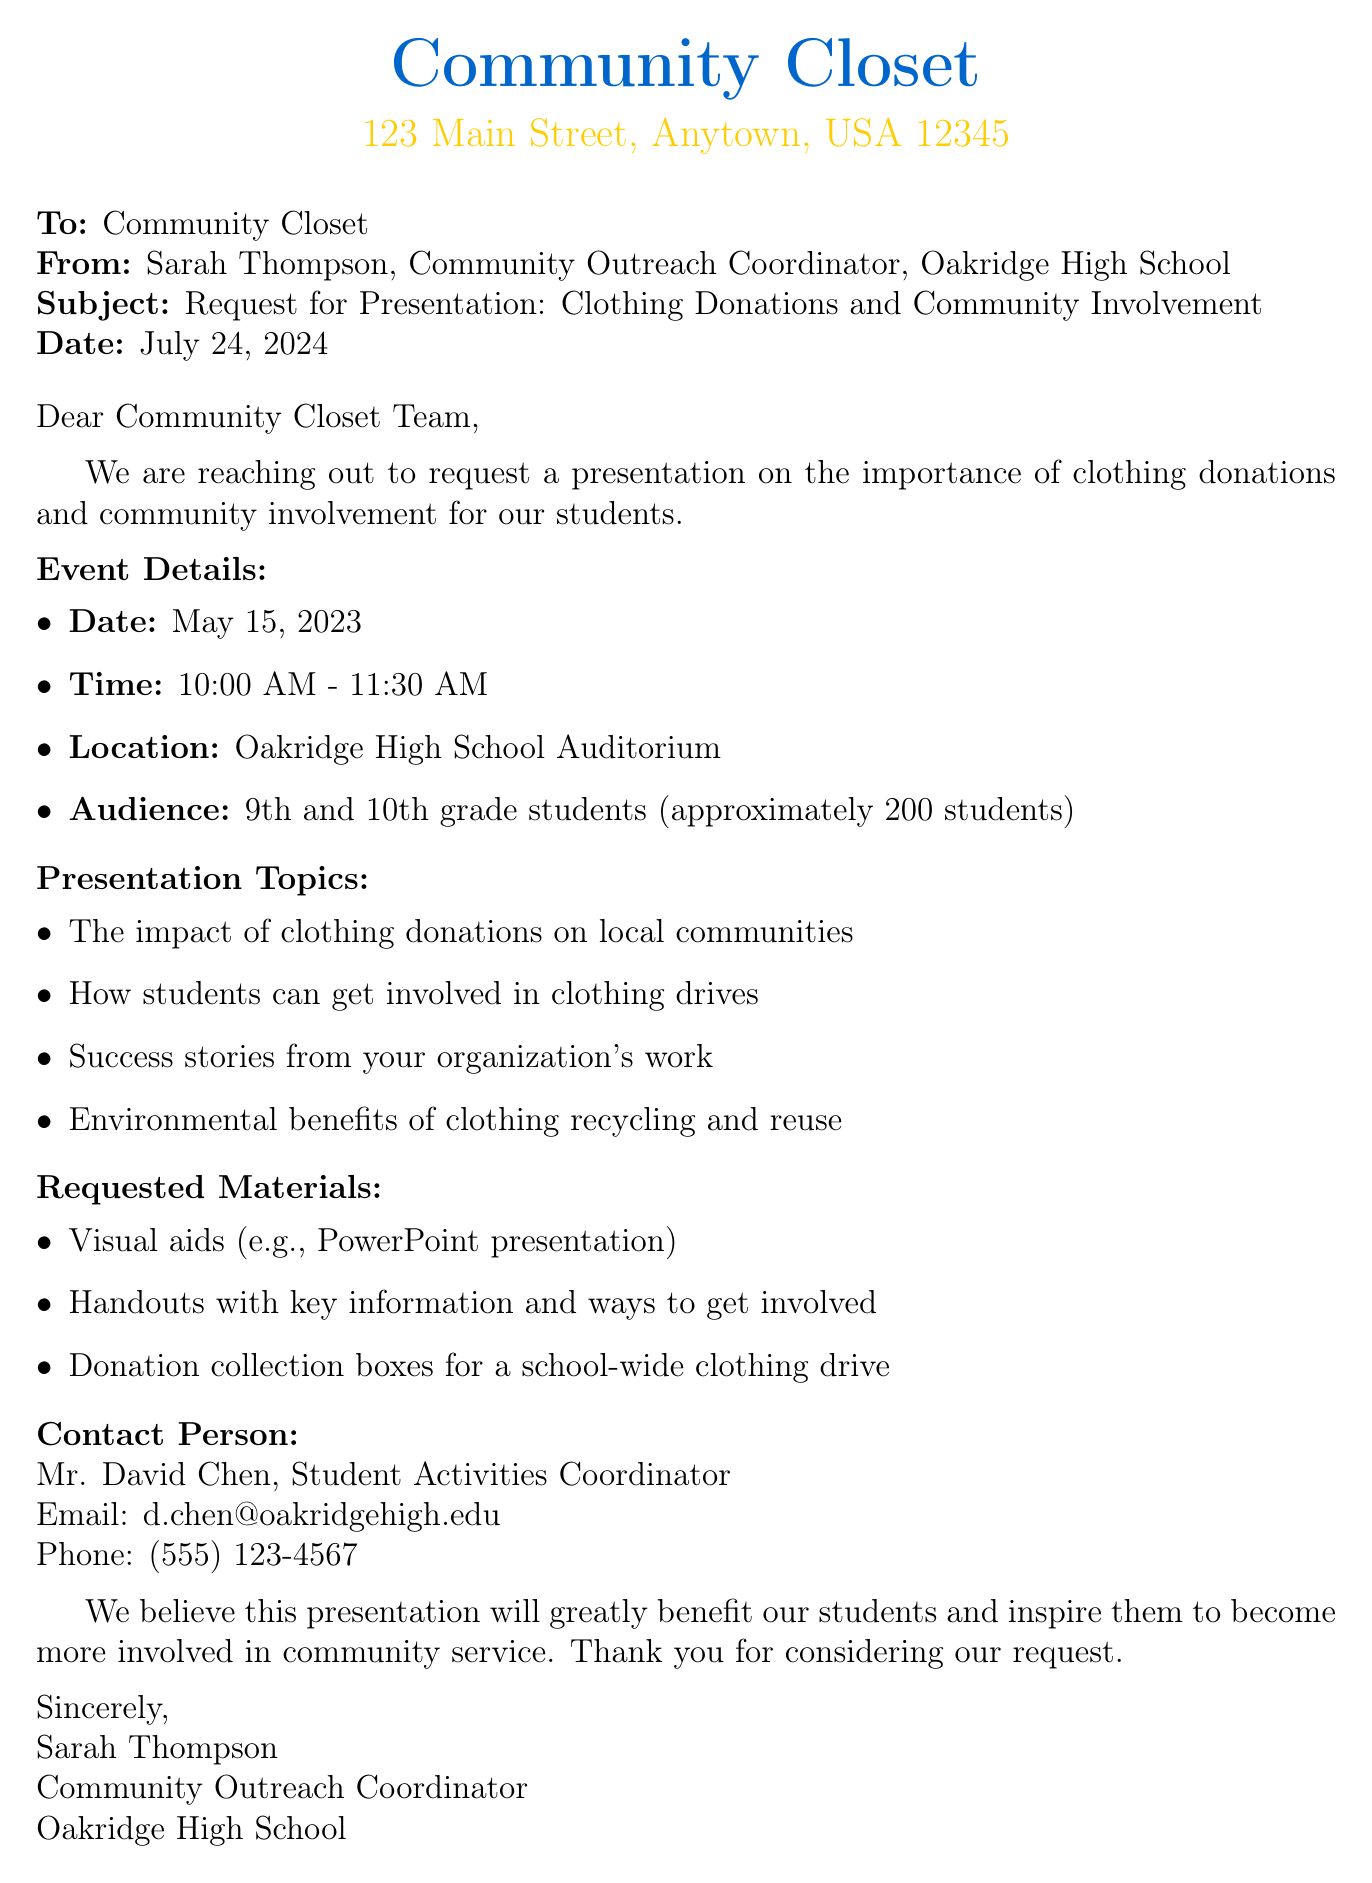What is the subject of the email? The subject of the email is explicitly stated in the document, which is typically found in the subject line.
Answer: Request for Presentation: Clothing Donations and Community Involvement Who is the sender of the email? The sender's name and position are provided in the document, indicating the person responsible for sending the request.
Answer: Sarah Thompson What date is the presentation scheduled for? The specific date of the event is mentioned in the document under event details.
Answer: May 15, 2023 How many students are expected to attend? The document mentions the approximate number of students in the event details section.
Answer: approximately 200 students What materials are requested for the presentation? The requested materials are listed in the document, outlining what should be provided for the presentation.
Answer: Visual aids (e.g., PowerPoint presentation), Handouts with key information and ways to get involved, Donation collection boxes for a school-wide clothing drive What are the presentation topics meant to address? The topics for the presentation are provided in a list format within the document, indicating the key focus areas.
Answer: The impact of clothing donations on local communities, How students can get involved in clothing drives, Success stories from your organization's work, Environmental benefits of clothing recycling and reuse Who is the contact person for this request? The contact person’s details are related to the school’s administration and are found toward the end of the document.
Answer: Mr. David Chen Why does the school believe the presentation will benefit students? The closing statement hints at the expected outcome of the presentation, suggesting its perceived value for the audience.
Answer: Inspire them to become more involved in community service 